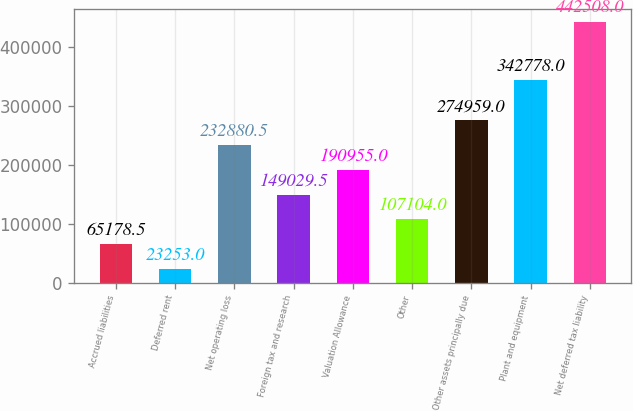<chart> <loc_0><loc_0><loc_500><loc_500><bar_chart><fcel>Accrued liabilities<fcel>Deferred rent<fcel>Net operating loss<fcel>Foreign tax and research<fcel>Valuation Allowance<fcel>Other<fcel>Other assets principally due<fcel>Plant and equipment<fcel>Net deferred tax liability<nl><fcel>65178.5<fcel>23253<fcel>232880<fcel>149030<fcel>190955<fcel>107104<fcel>274959<fcel>342778<fcel>442508<nl></chart> 